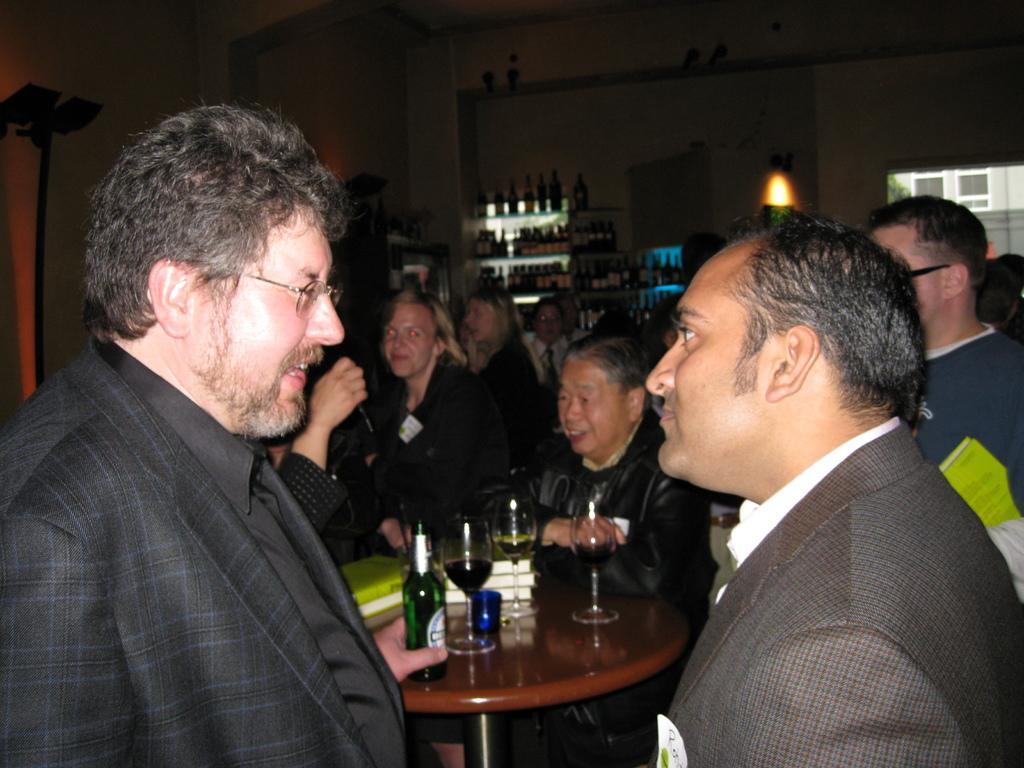Can you describe this image briefly? Here in the front we can see two men speaking to each other and behind them we can a see group of people sitting and standing at the table in front of them having glasses and bottles present 